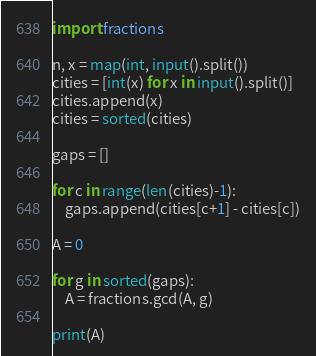<code> <loc_0><loc_0><loc_500><loc_500><_Python_>import fractions

n, x = map(int, input().split())
cities = [int(x) for x in input().split()]
cities.append(x)
cities = sorted(cities)

gaps = []

for c in range(len(cities)-1):
    gaps.append(cities[c+1] - cities[c])

A = 0

for g in sorted(gaps):
    A = fractions.gcd(A, g)

print(A)

</code> 